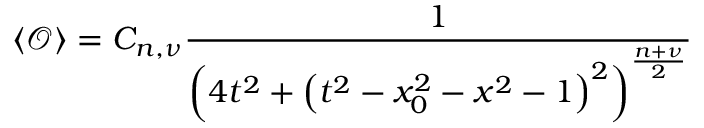Convert formula to latex. <formula><loc_0><loc_0><loc_500><loc_500>\left \langle \mathcal { O } \right \rangle = C _ { n , \nu } \frac { 1 } { \left ( 4 t ^ { 2 } + \left ( t ^ { 2 } - x _ { 0 } ^ { 2 } - x ^ { 2 } - 1 \right ) ^ { 2 } \right ) ^ { \frac { n + \nu } { 2 } } }</formula> 